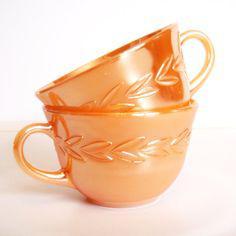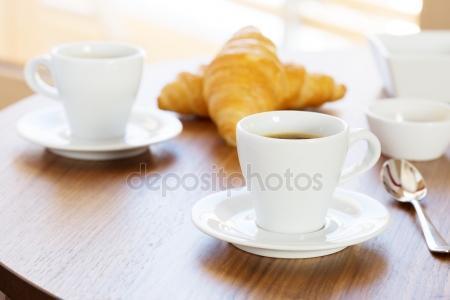The first image is the image on the left, the second image is the image on the right. For the images displayed, is the sentence "At least one white cup sits in a white saucer." factually correct? Answer yes or no. Yes. The first image is the image on the left, the second image is the image on the right. For the images displayed, is the sentence "Each image shows two side-by-side cups." factually correct? Answer yes or no. No. 